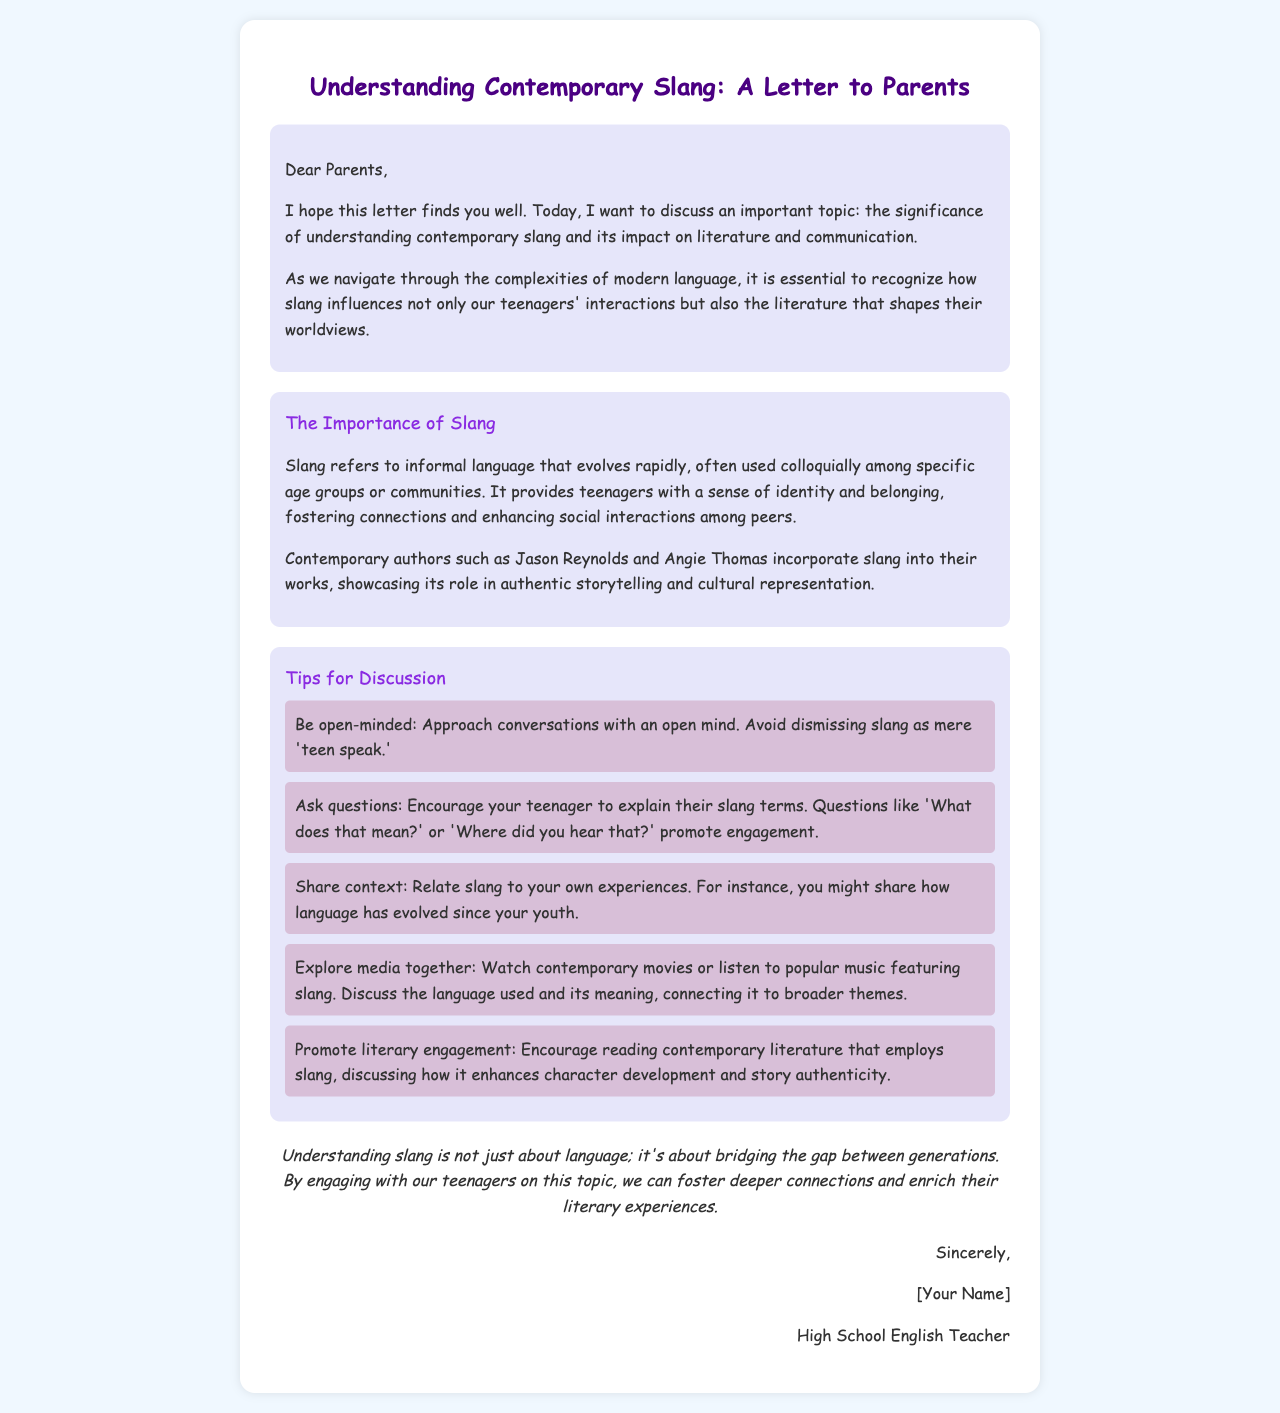What is the title of the letter? The title of the letter, which summarizes its content, is found in the heading of the document.
Answer: Understanding Contemporary Slang: A Letter to Parents Who is the letter addressed to? The recipient of the letter is specified in the salutation at the beginning of the document.
Answer: Parents Name one contemporary author mentioned in the letter. The letter references specific authors known for incorporating slang into their works, showcasing modern literary styles.
Answer: Jason Reynolds What is one tip for parents to engage in discussions about slang? The letter lists various tips for engaging in conversations with teenagers regarding slang in literature and communication.
Answer: Be open-minded What is the main purpose of understanding contemporary slang according to the letter? The letter outlines the significance of understanding slang, particularly in relation to communication and literature among teenagers.
Answer: Bridging the gap between generations How does the letter suggest parents relate slang to their own experiences? The document provides recommendations for parents to discuss slang in context, linking it to their own backgrounds and times.
Answer: Share context What color is used for the section titles in the document? The color of the section titles is specified within the style elements of the document.
Answer: #8a2be2 How many tips for discussion are provided in the letter? The letter lists a specific number of tips that parents can use as guidelines for discussions with their teenagers.
Answer: Five 